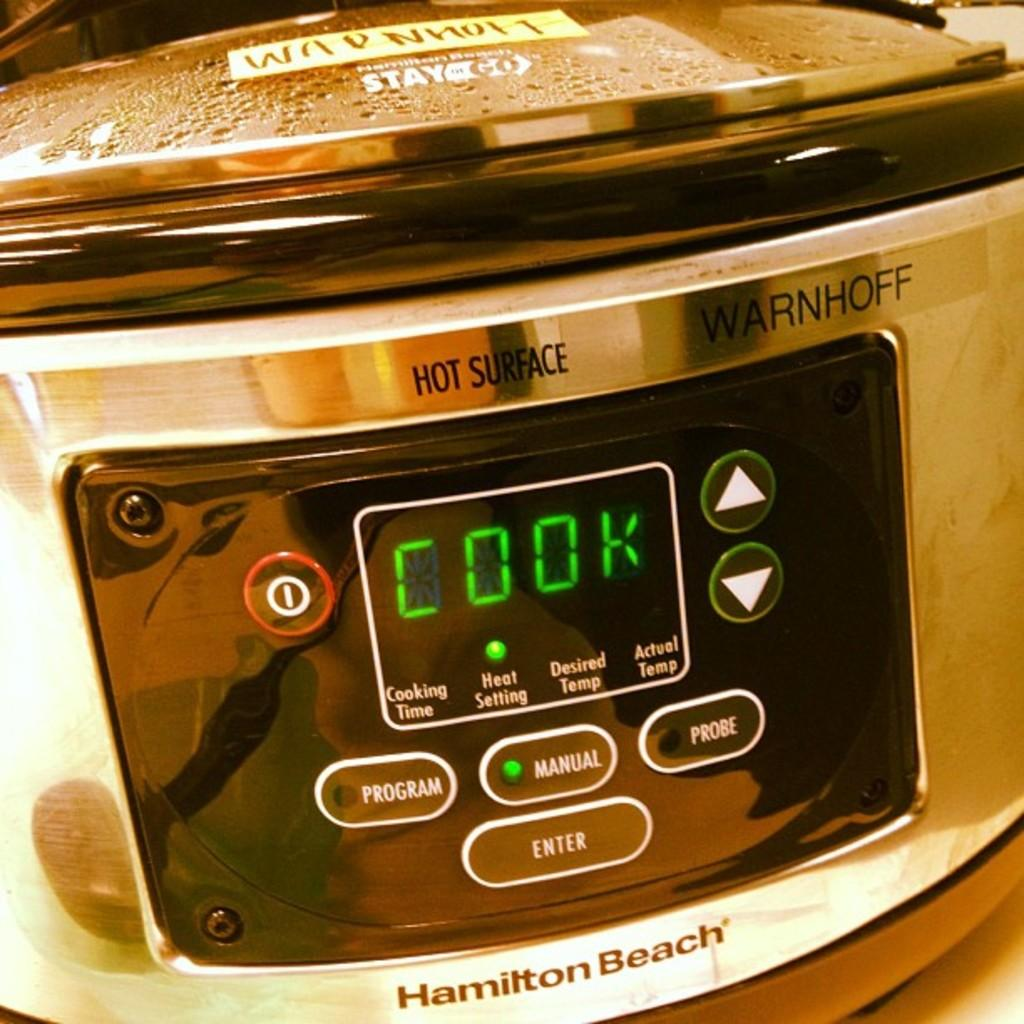<image>
Give a short and clear explanation of the subsequent image. A shiny silver Hamilton Beach brand slow cooker. 